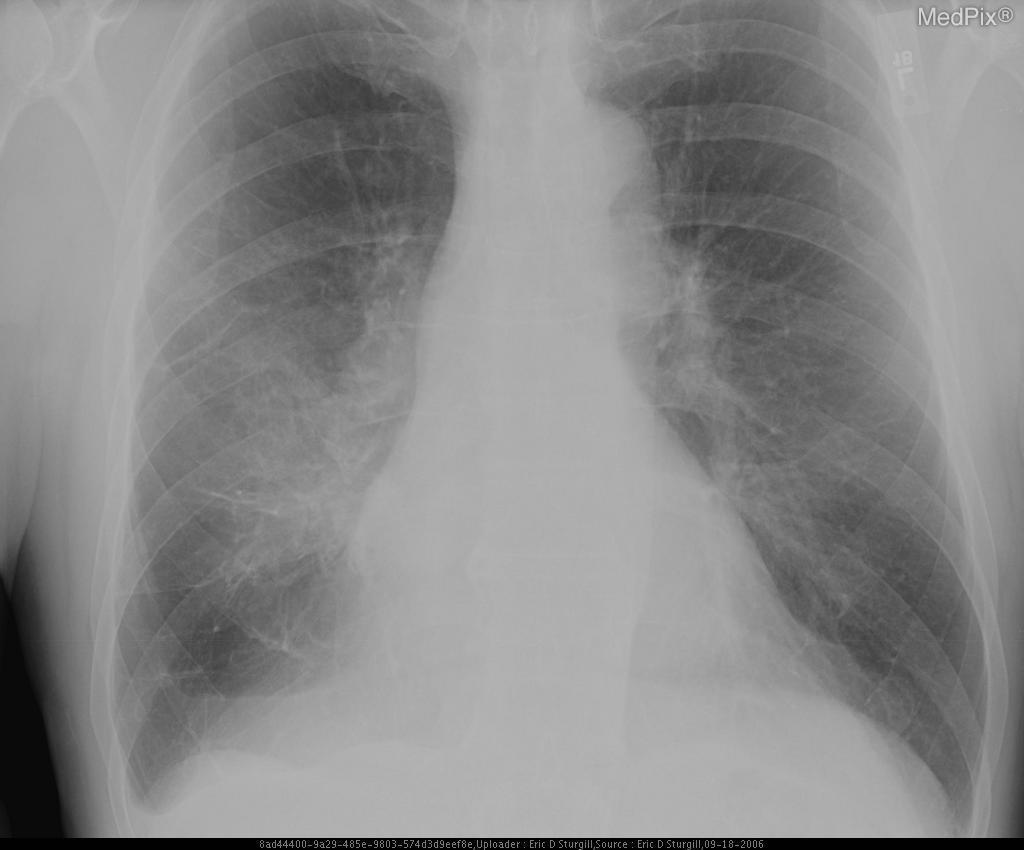Is there hilar adenopathy?
Write a very short answer. Yes. Is there hyperinflation of the lung(s)?
Write a very short answer. No. Are the lungs increased in size?
Short answer required. No. Is the heart size abnormal?
Short answer required. No. Is the heart enlarged?
Answer briefly. No. Can you appreciate a pleural effusion anywhere?
Give a very brief answer. No. Is pleural effusion present?
Quick response, please. No. 